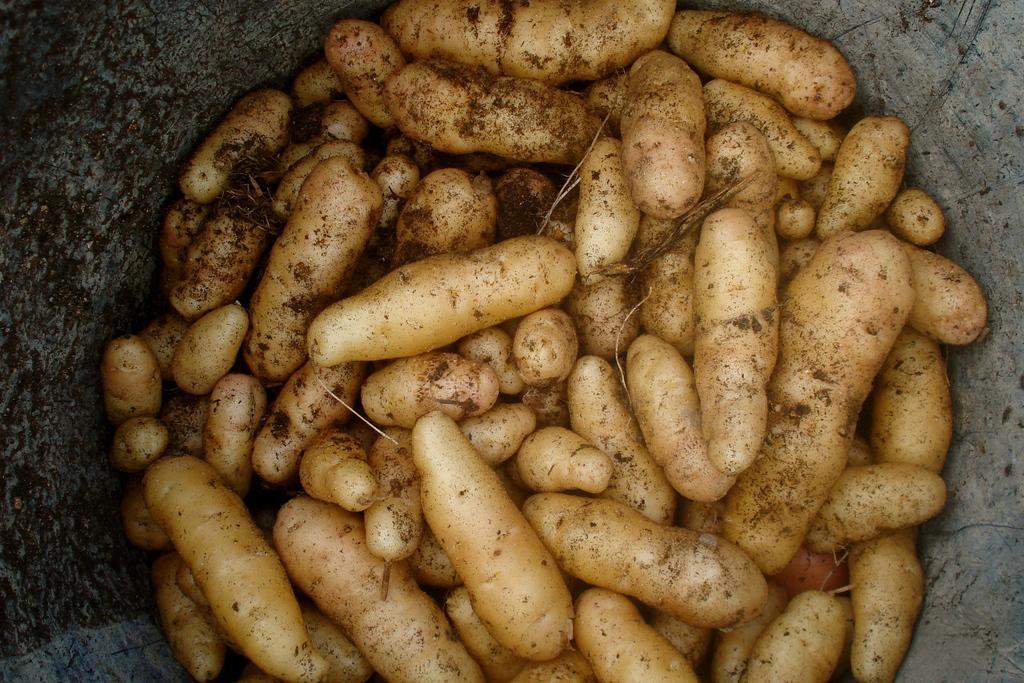Describe this image in one or two sentences. Here we can see potatoes. On the right side and left side of the image, we can see stone walls. 